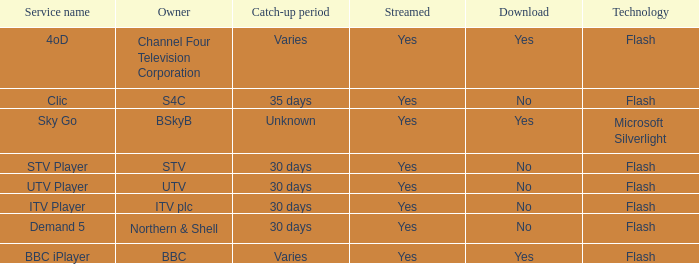What is the Catch-up period for UTV? 30 days. 